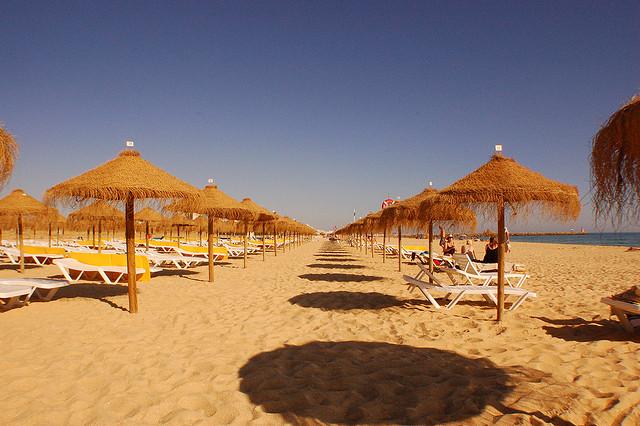Which direction is the sun shining?
Keep it brief. East. What time of day is it?
Concise answer only. Afternoon. What items are making the shadows?
Short answer required. Umbrellas. Where is this scene?
Quick response, please. Beach. 